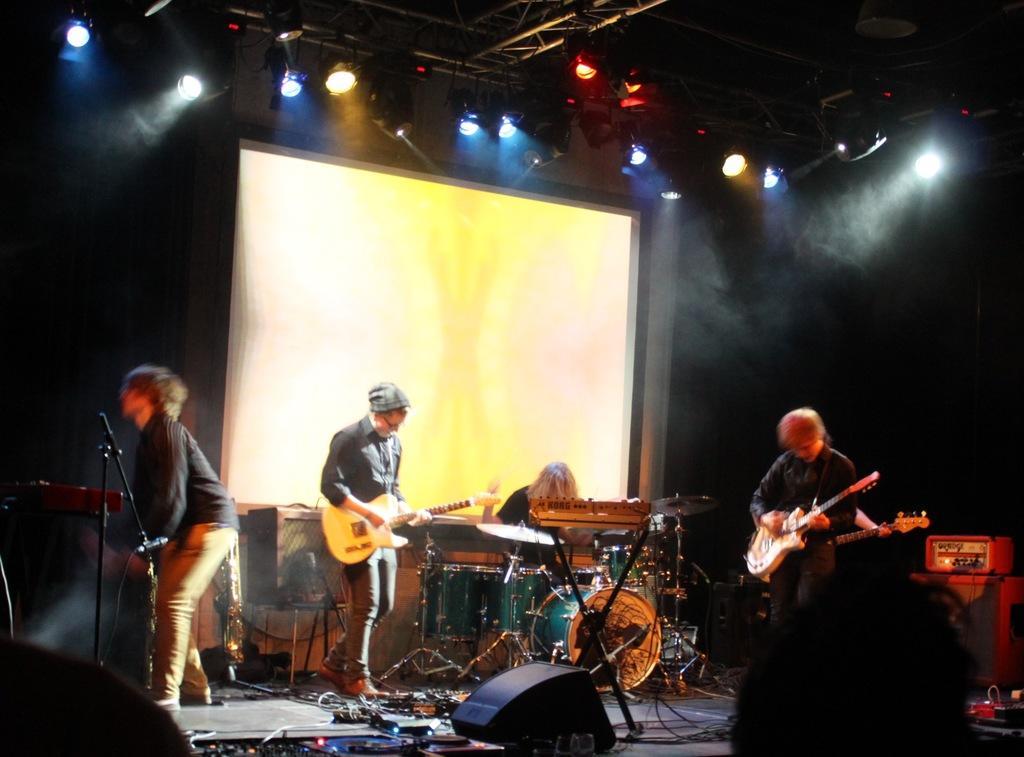Can you describe this image briefly? In this picture we have a man standing and playing guitar , another man sitting and playing drums , another man standing and playing a guitar , another man standing and the back ground we have a screen , lights , speakers , cables. 